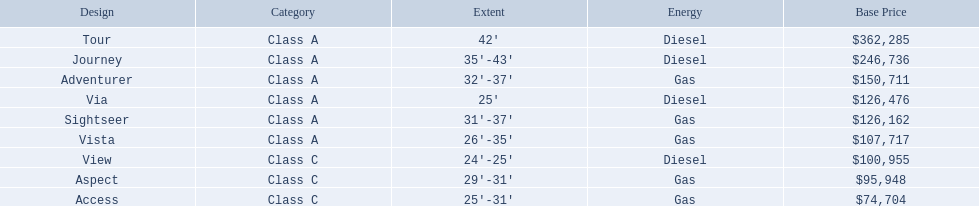What models are available from winnebago industries? Tour, Journey, Adventurer, Via, Sightseer, Vista, View, Aspect, Access. What are their starting prices? $362,285, $246,736, $150,711, $126,476, $126,162, $107,717, $100,955, $95,948, $74,704. Which model has the most costly starting price? Tour. 